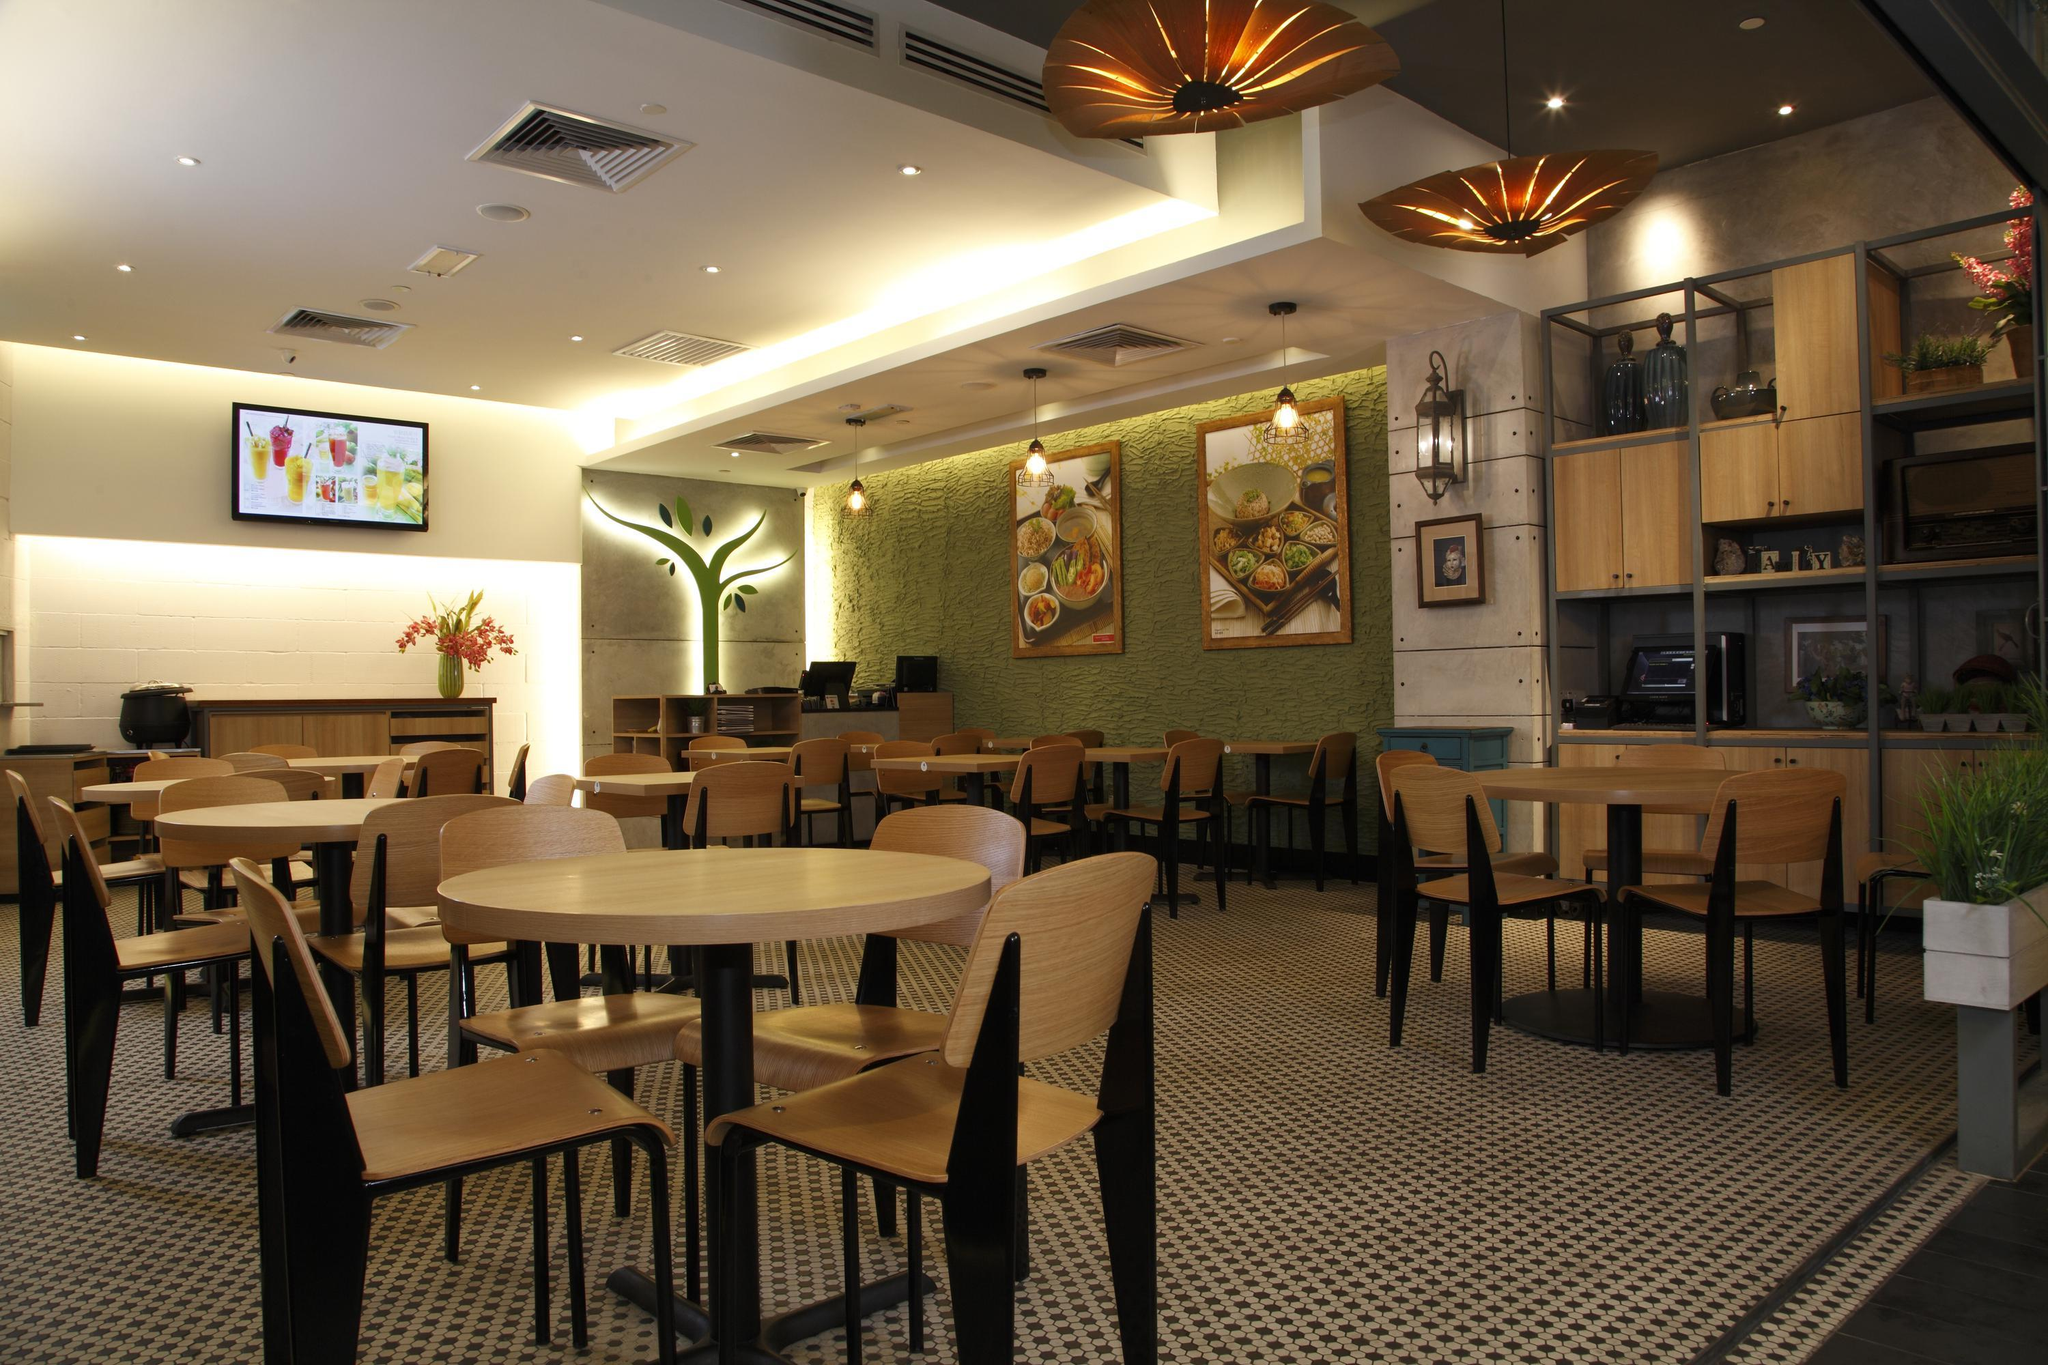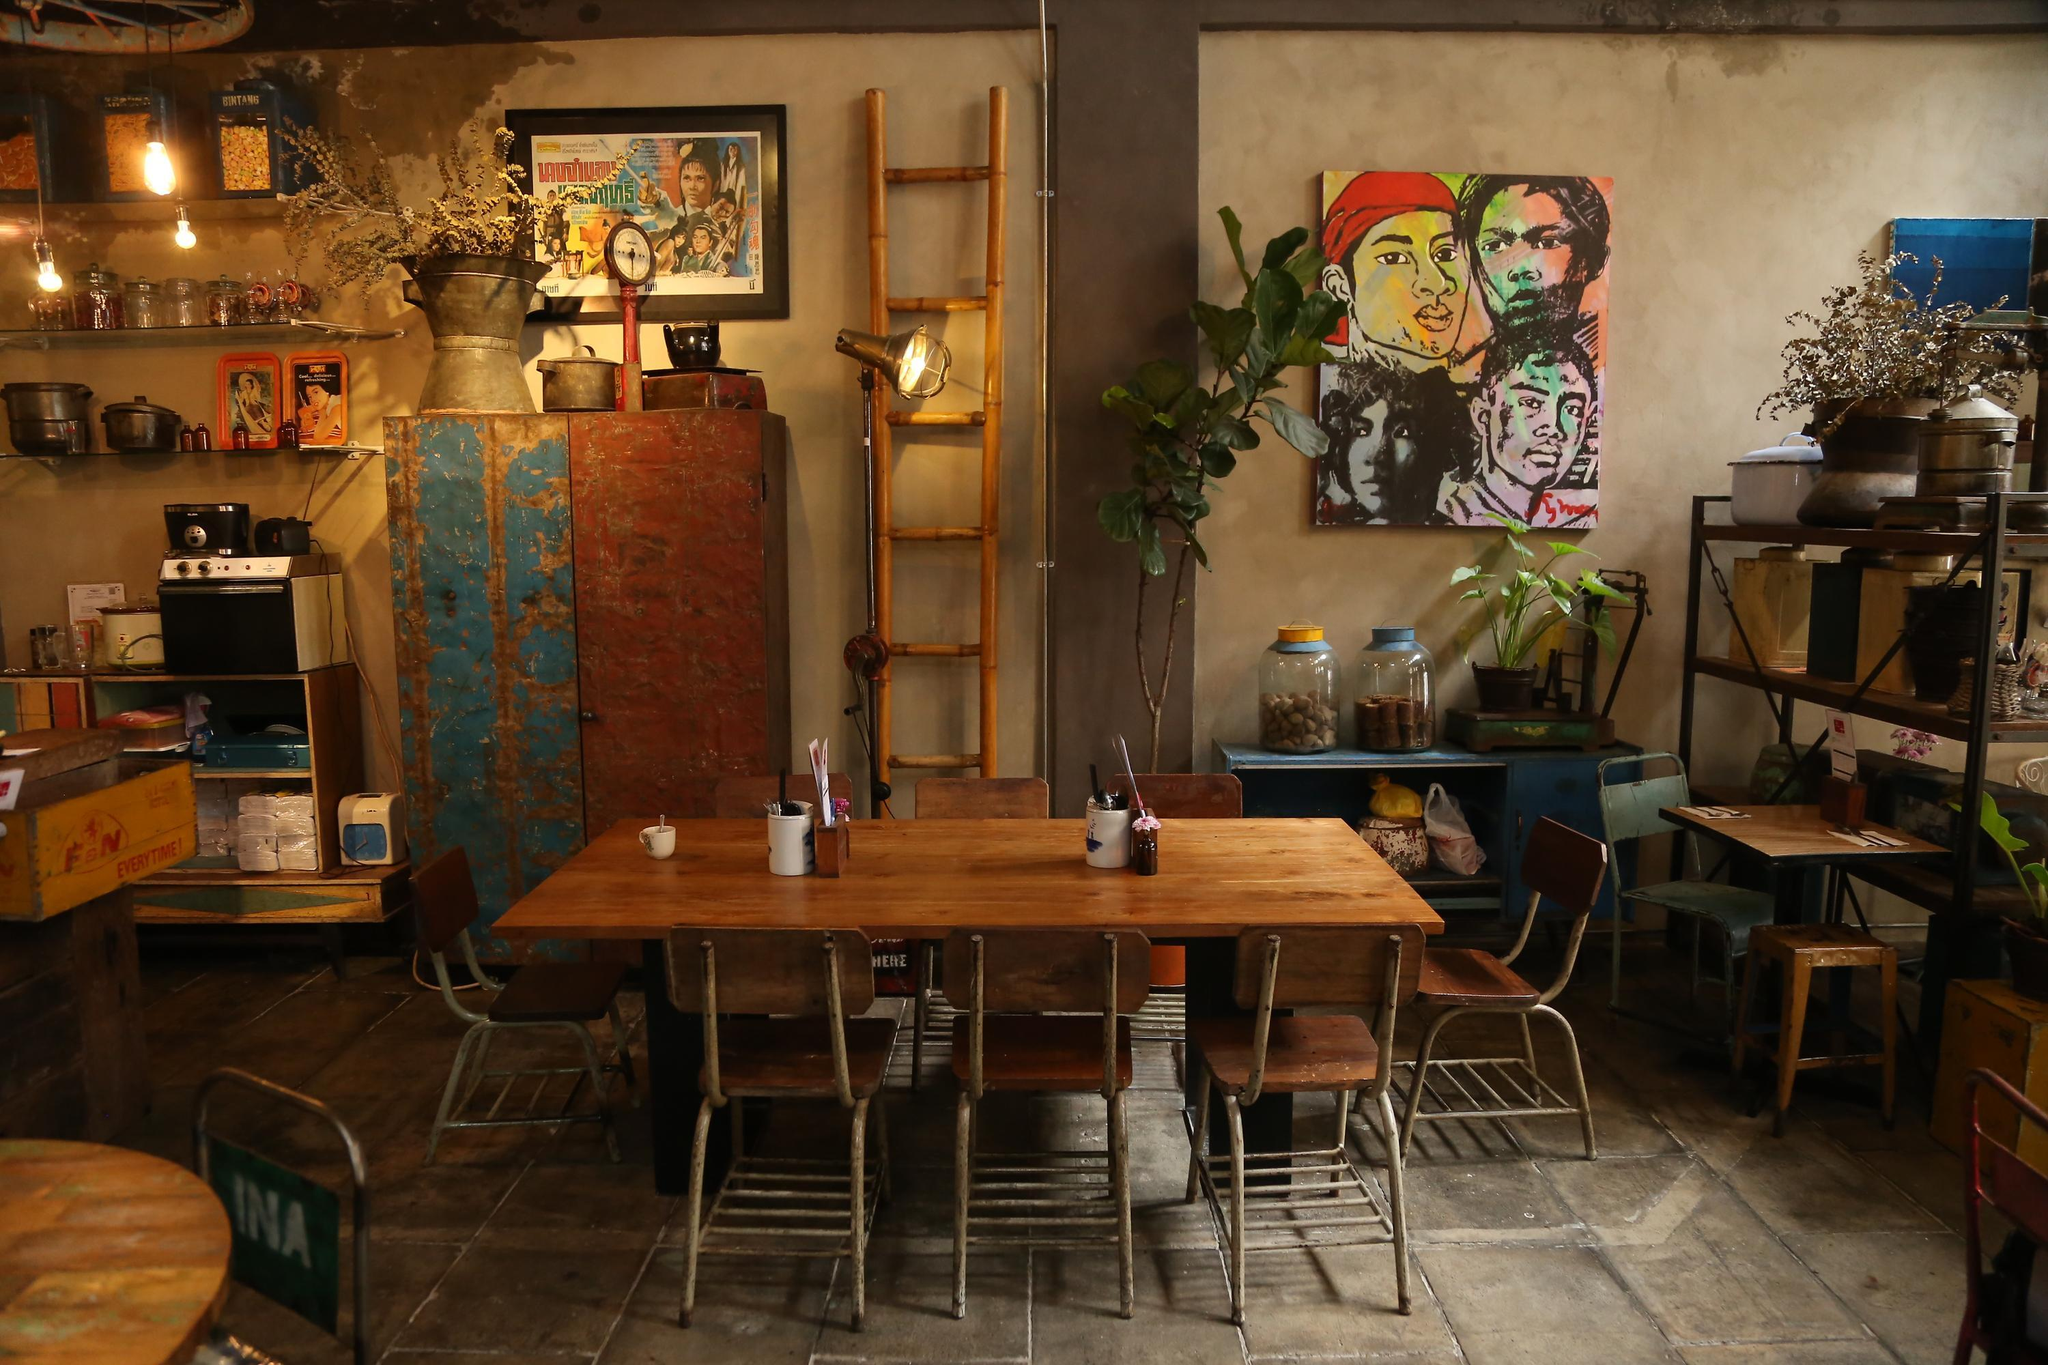The first image is the image on the left, the second image is the image on the right. For the images displayed, is the sentence "At least one photo shows a dining area that is completely lit and also void of guests." factually correct? Answer yes or no. Yes. The first image is the image on the left, the second image is the image on the right. Considering the images on both sides, is "There are at least four round tables with four armless chairs." valid? Answer yes or no. Yes. 